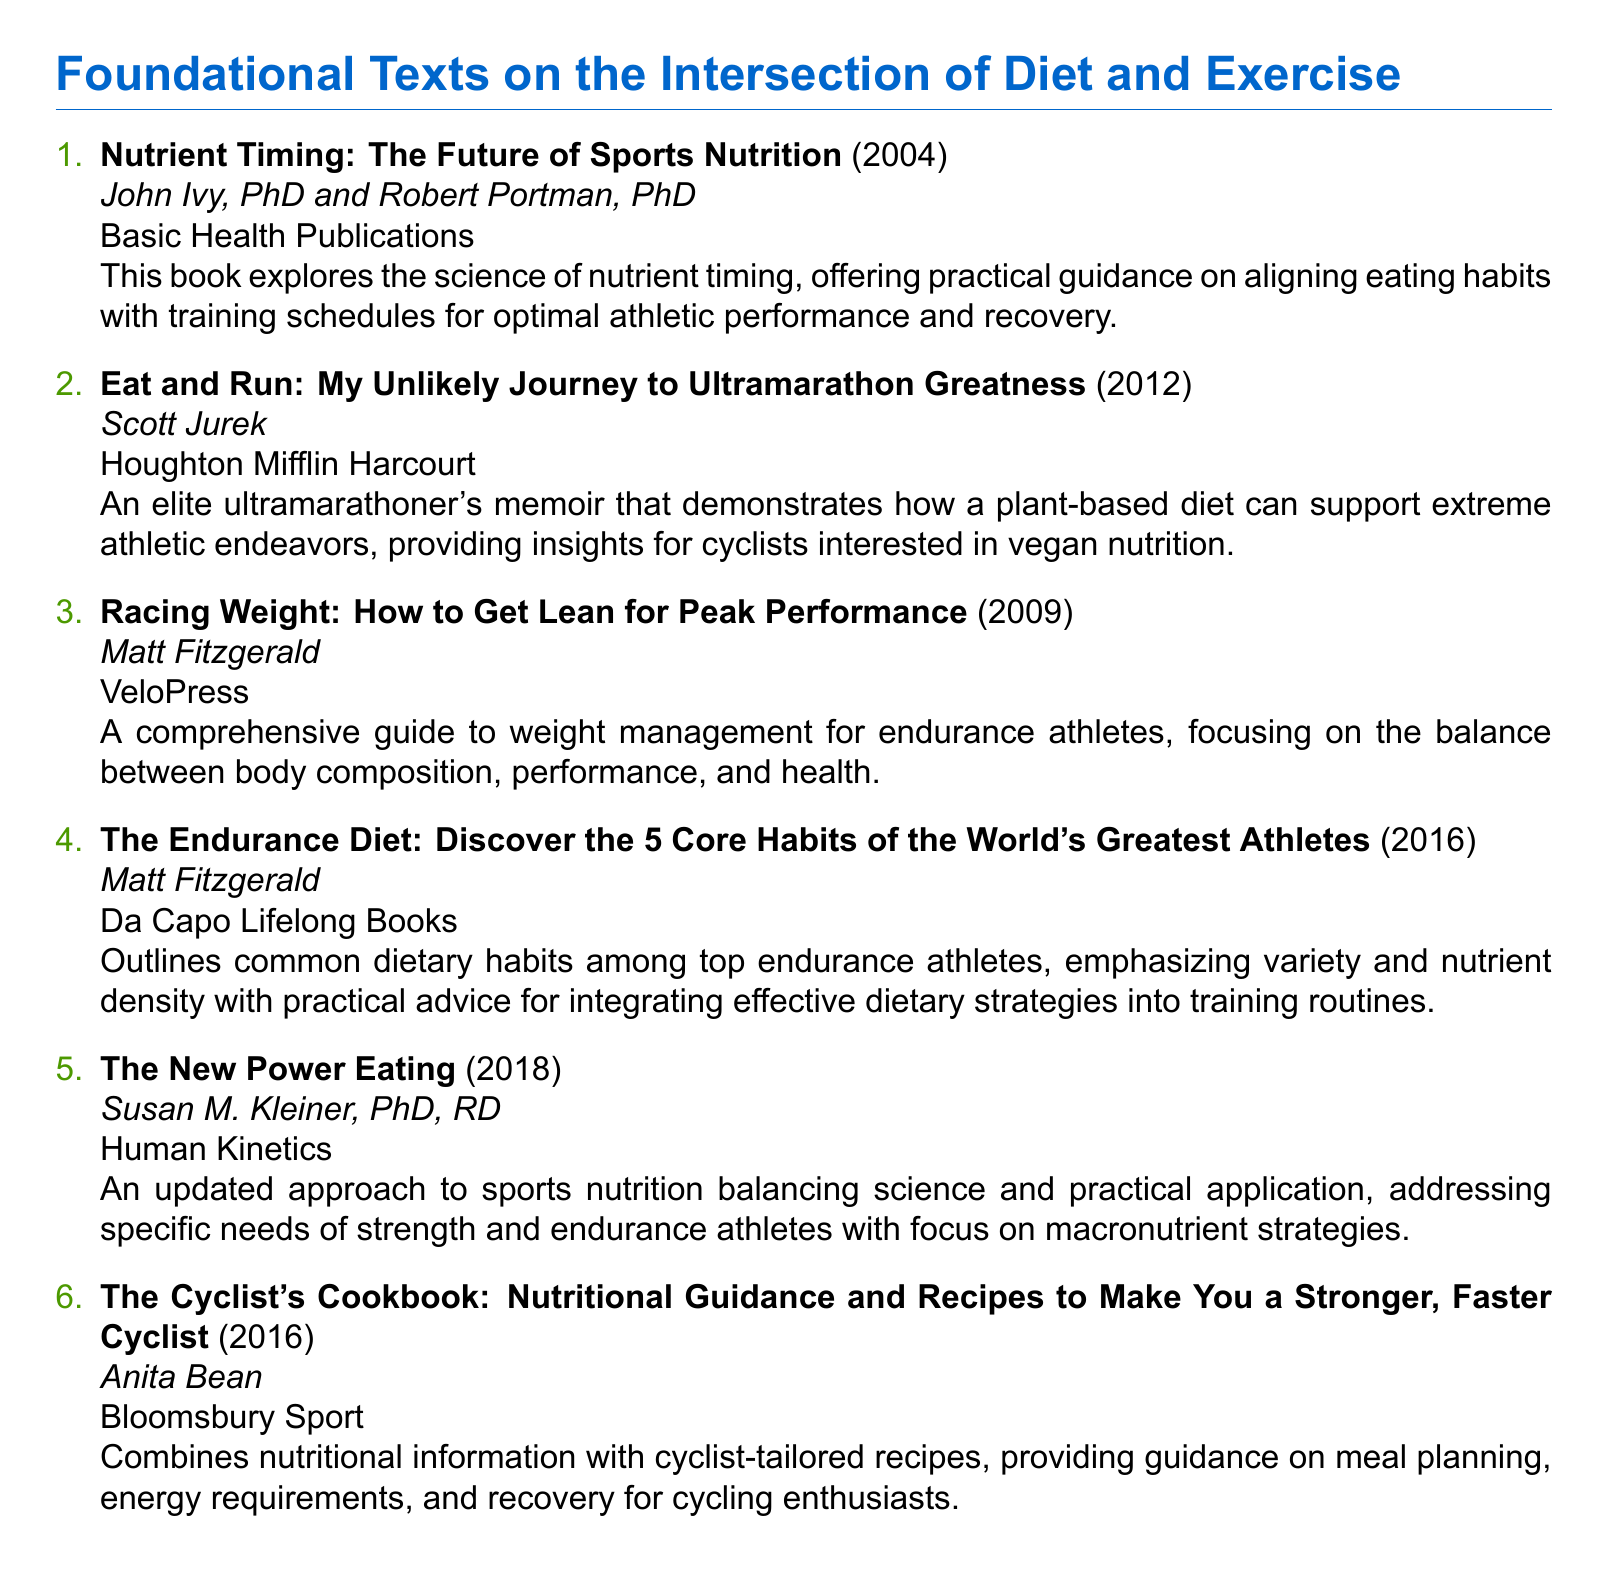what is the title of the first book? The title of the first book is listed at the beginning of the entry, which is "Nutrient Timing: The Future of Sports Nutrition."
Answer: Nutrient Timing: The Future of Sports Nutrition who are the authors of "Eat and Run"? The authors of "Eat and Run" are mentioned immediately under the title, which are Scott Jurek.
Answer: Scott Jurek what year was "Racing Weight" published? The publication year of "Racing Weight" is included in parentheses next to the title, which is 2009.
Answer: 2009 how many core habits are discussed in "The Endurance Diet"? The number of core habits in "The Endurance Diet" is specified in the title as five.
Answer: 5 who wrote "The New Power Eating"? The author of "The New Power Eating" is mentioned right after the title, which is Susan M. Kleiner.
Answer: Susan M. Kleiner which book focuses on plant-based diets? The focus on plant-based diets is indicated in the summary of "Eat and Run," which discusses how a plant-based diet can support athletic endeavors.
Answer: Eat and Run how many books are listed in total? The total number of books can be counted from the enumeration in the document, which lists six titles.
Answer: 6 what is the main topic of "The Cyclist's Cookbook"? The main topic of "The Cyclist's Cookbook" is detailed in the description, which mentions nutritional guidance and recipes for cyclists.
Answer: Nutritional guidance and recipes for cyclists what type of publication is "Racing Weight"? The type of publication for "Racing Weight" is indicated by the publisher's name given at the end of the entry, which is VeloPress.
Answer: VeloPress 